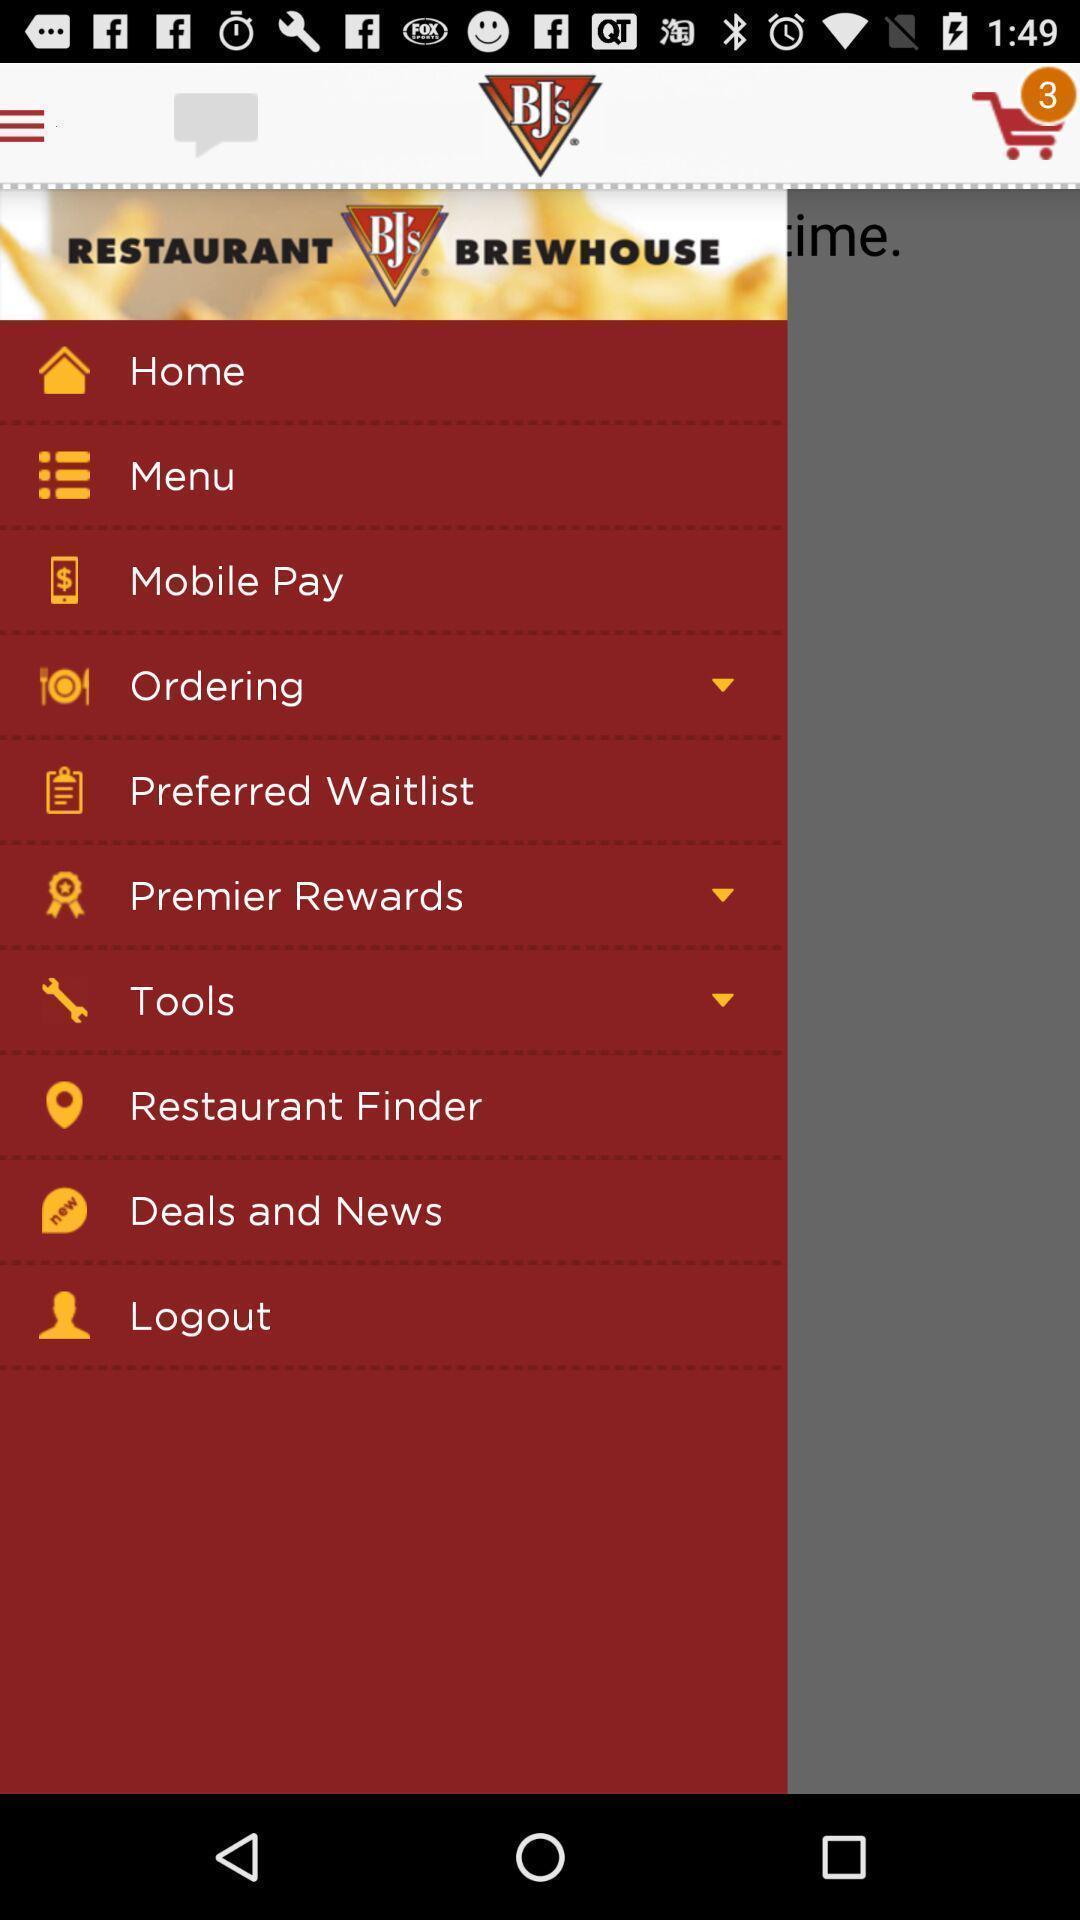Provide a detailed account of this screenshot. Widget displaying features of the app. 